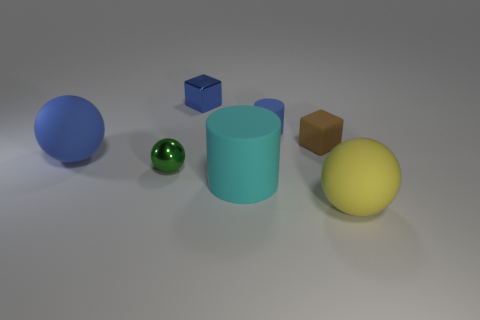Subtract 1 spheres. How many spheres are left? 2 Add 3 cubes. How many objects exist? 10 Subtract all cylinders. How many objects are left? 5 Subtract 1 brown blocks. How many objects are left? 6 Subtract all cylinders. Subtract all yellow metal cylinders. How many objects are left? 5 Add 3 matte balls. How many matte balls are left? 5 Add 1 big cylinders. How many big cylinders exist? 2 